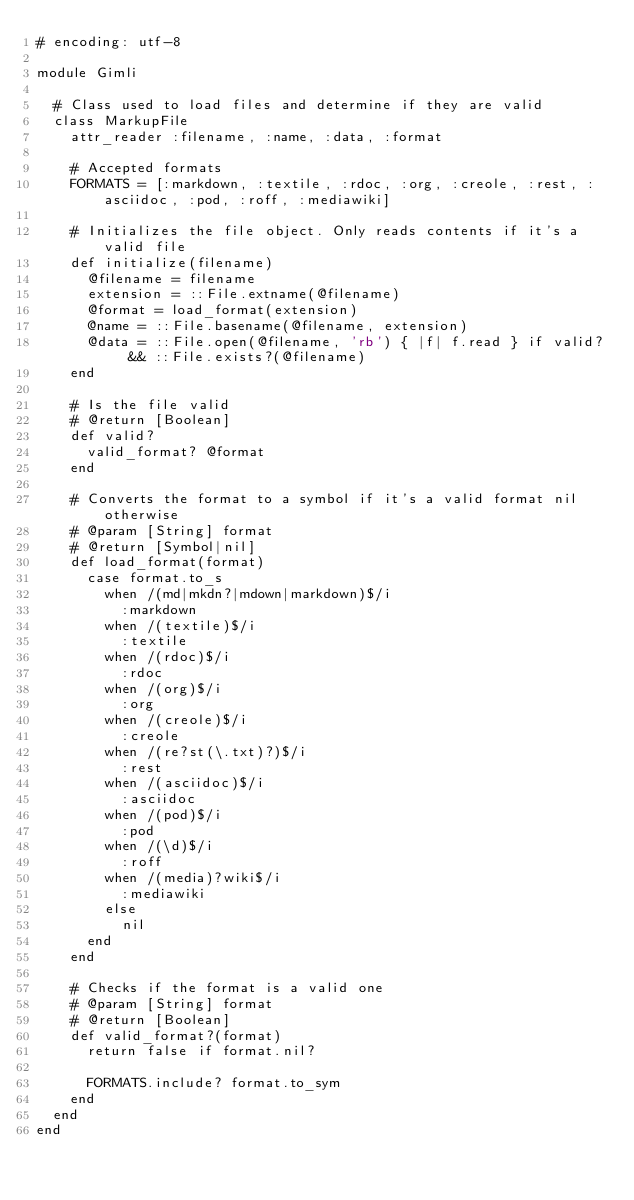<code> <loc_0><loc_0><loc_500><loc_500><_Ruby_># encoding: utf-8

module Gimli

  # Class used to load files and determine if they are valid
  class MarkupFile
    attr_reader :filename, :name, :data, :format

    # Accepted formats
    FORMATS = [:markdown, :textile, :rdoc, :org, :creole, :rest, :asciidoc, :pod, :roff, :mediawiki]

    # Initializes the file object. Only reads contents if it's a valid file
    def initialize(filename)
      @filename = filename
      extension = ::File.extname(@filename)
      @format = load_format(extension)
      @name = ::File.basename(@filename, extension)
      @data = ::File.open(@filename, 'rb') { |f| f.read } if valid? && ::File.exists?(@filename)
    end

    # Is the file valid
    # @return [Boolean]
    def valid?
      valid_format? @format
    end

    # Converts the format to a symbol if it's a valid format nil otherwise
    # @param [String] format
    # @return [Symbol|nil]
    def load_format(format)
      case format.to_s
        when /(md|mkdn?|mdown|markdown)$/i
          :markdown
        when /(textile)$/i
          :textile
        when /(rdoc)$/i
          :rdoc
        when /(org)$/i
          :org
        when /(creole)$/i
          :creole
        when /(re?st(\.txt)?)$/i
          :rest
        when /(asciidoc)$/i
          :asciidoc
        when /(pod)$/i
          :pod
        when /(\d)$/i
          :roff
        when /(media)?wiki$/i
          :mediawiki
        else
          nil
      end
    end

    # Checks if the format is a valid one
    # @param [String] format
    # @return [Boolean]
    def valid_format?(format)
      return false if format.nil?

      FORMATS.include? format.to_sym
    end
  end
end

</code> 